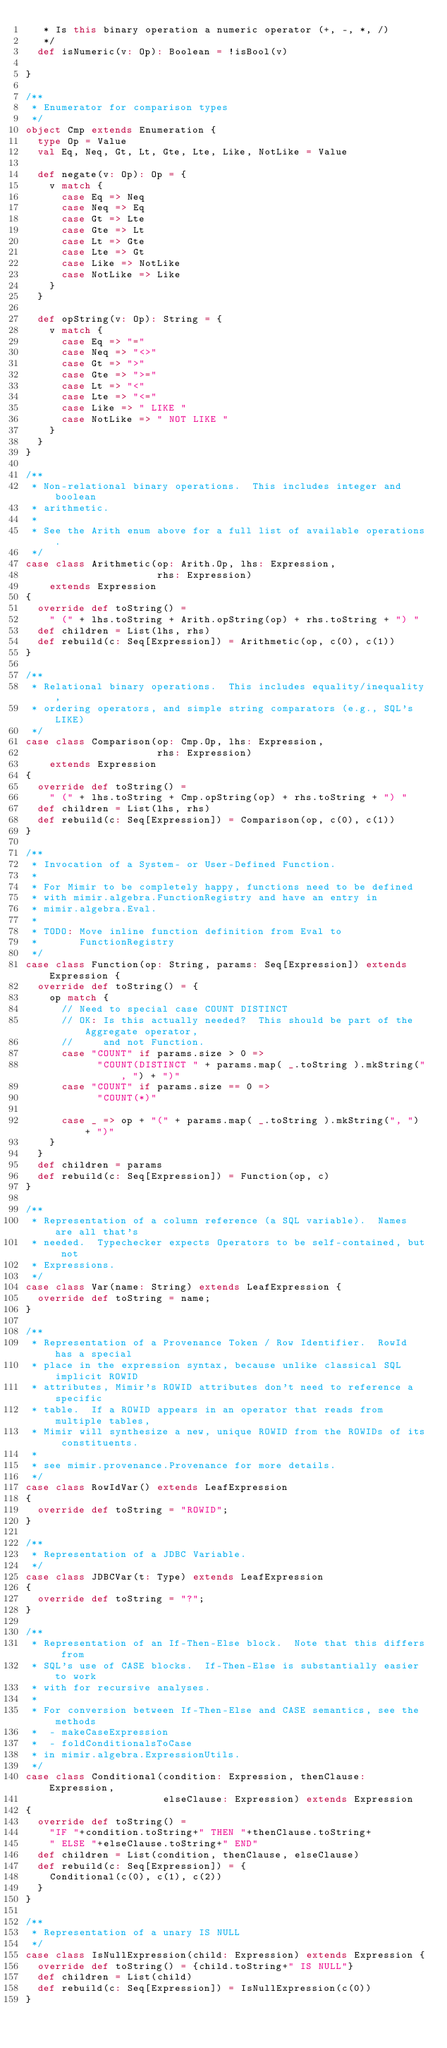Convert code to text. <code><loc_0><loc_0><loc_500><loc_500><_Scala_>   * Is this binary operation a numeric operator (+, -, *, /)
   */
  def isNumeric(v: Op): Boolean = !isBool(v)

}

/**
 * Enumerator for comparison types
 */
object Cmp extends Enumeration {
  type Op = Value
  val Eq, Neq, Gt, Lt, Gte, Lte, Like, NotLike = Value
  
  def negate(v: Op): Op = {
    v match {
      case Eq => Neq
      case Neq => Eq
      case Gt => Lte
      case Gte => Lt
      case Lt => Gte
      case Lte => Gt
      case Like => NotLike
      case NotLike => Like
    }
  }
  
  def opString(v: Op): String = {
    v match {
      case Eq => "="
      case Neq => "<>"
      case Gt => ">"
      case Gte => ">="
      case Lt => "<"
      case Lte => "<="
      case Like => " LIKE "
      case NotLike => " NOT LIKE "
    }
  }
}

/**
 * Non-relational binary operations.  This includes integer and boolean
 * arithmetic.
 * 
 * See the Arith enum above for a full list of available operations.
 */
case class Arithmetic(op: Arith.Op, lhs: Expression, 
                      rhs: Expression) 
	extends Expression 
{
  override def toString() = 
	" (" + lhs.toString + Arith.opString(op) + rhs.toString + ") "
  def children = List(lhs, rhs)
  def rebuild(c: Seq[Expression]) = Arithmetic(op, c(0), c(1))
}

/**
 * Relational binary operations.  This includes equality/inequality,
 * ordering operators, and simple string comparators (e.g., SQL's LIKE)
 */
case class Comparison(op: Cmp.Op, lhs: Expression, 
                      rhs: Expression) 
	extends Expression 
{
  override def toString() = 
	" (" + lhs.toString + Cmp.opString(op) + rhs.toString + ") "
  def children = List(lhs, rhs)
  def rebuild(c: Seq[Expression]) = Comparison(op, c(0), c(1))
}

/**
 * Invocation of a System- or User-Defined Function.  
 * 
 * For Mimir to be completely happy, functions need to be defined
 * with mimir.algebra.FunctionRegistry and have an entry in 
 * mimir.algebra.Eval.  
 *
 * TODO: Move inline function definition from Eval to 
 *       FunctionRegistry
 */
case class Function(op: String, params: Seq[Expression]) extends Expression {
  override def toString() = {
    op match {
      // Need to special case COUNT DISTINCT
      // OK: Is this actually needed?  This should be part of the Aggregate operator, 
      //     and not Function.
      case "COUNT" if params.size > 0 => 
            "COUNT(DISTINCT " + params.map( _.toString ).mkString(", ") + ")"
      case "COUNT" if params.size == 0 => 
            "COUNT(*)"

      case _ => op + "(" + params.map( _.toString ).mkString(", ") + ")"
    }
  }
  def children = params
  def rebuild(c: Seq[Expression]) = Function(op, c)
}

/**
 * Representation of a column reference (a SQL variable).  Names are all that's
 * needed.  Typechecker expects Operators to be self-contained, but not 
 * Expressions.
 */
case class Var(name: String) extends LeafExpression {
  override def toString = name;
}

/**
 * Representation of a Provenance Token / Row Identifier.  RowId has a special
 * place in the expression syntax, because unlike classical SQL implicit ROWID
 * attributes, Mimir's ROWID attributes don't need to reference a specific
 * table.  If a ROWID appears in an operator that reads from multiple tables,
 * Mimir will synthesize a new, unique ROWID from the ROWIDs of its constituents.
 * 
 * see mimir.provenance.Provenance for more details.
 */
case class RowIdVar() extends LeafExpression
{
  override def toString = "ROWID";
}

/**
 * Representation of a JDBC Variable.
 */
case class JDBCVar(t: Type) extends LeafExpression
{
  override def toString = "?";
}

/**
 * Representation of an If-Then-Else block.  Note that this differs from
 * SQL's use of CASE blocks.  If-Then-Else is substantially easier to work
 * with for recursive analyses.  
 *
 * For conversion between If-Then-Else and CASE semantics, see the methods
 *  - makeCaseExpression
 *  - foldConditionalsToCase
 * in mimir.algebra.ExpressionUtils.
 */
case class Conditional(condition: Expression, thenClause: Expression,
                       elseClause: Expression) extends Expression 
{
  override def toString() = 
  	"IF "+condition.toString+" THEN "+thenClause.toString+
    " ELSE "+elseClause.toString+" END"
  def children = List(condition, thenClause, elseClause)
  def rebuild(c: Seq[Expression]) = {
    Conditional(c(0), c(1), c(2))
  }
}

/**
 * Representation of a unary IS NULL
 */
case class IsNullExpression(child: Expression) extends Expression { 
  override def toString() = {child.toString+" IS NULL"}
  def children = List(child)
  def rebuild(c: Seq[Expression]) = IsNullExpression(c(0))
}
</code> 